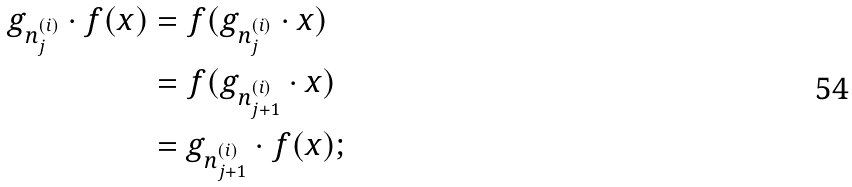<formula> <loc_0><loc_0><loc_500><loc_500>g _ { n ^ { ( i ) } _ { j } } \cdot f ( x ) & = f ( g _ { n ^ { ( i ) } _ { j } } \cdot x ) \\ & = f ( g _ { n ^ { ( i ) } _ { j + 1 } } \cdot x ) \\ & = g _ { n ^ { ( i ) } _ { j + 1 } } \cdot f ( x ) ;</formula> 